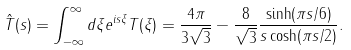Convert formula to latex. <formula><loc_0><loc_0><loc_500><loc_500>\hat { T } ( s ) = \int _ { - \infty } ^ { \infty } d \xi e ^ { i s \xi } T ( \xi ) = \frac { 4 \pi } { 3 \sqrt { 3 } } - \frac { 8 } { \sqrt { 3 } } \frac { \sinh ( \pi s / 6 ) } { s \cosh ( \pi s / 2 ) } .</formula> 